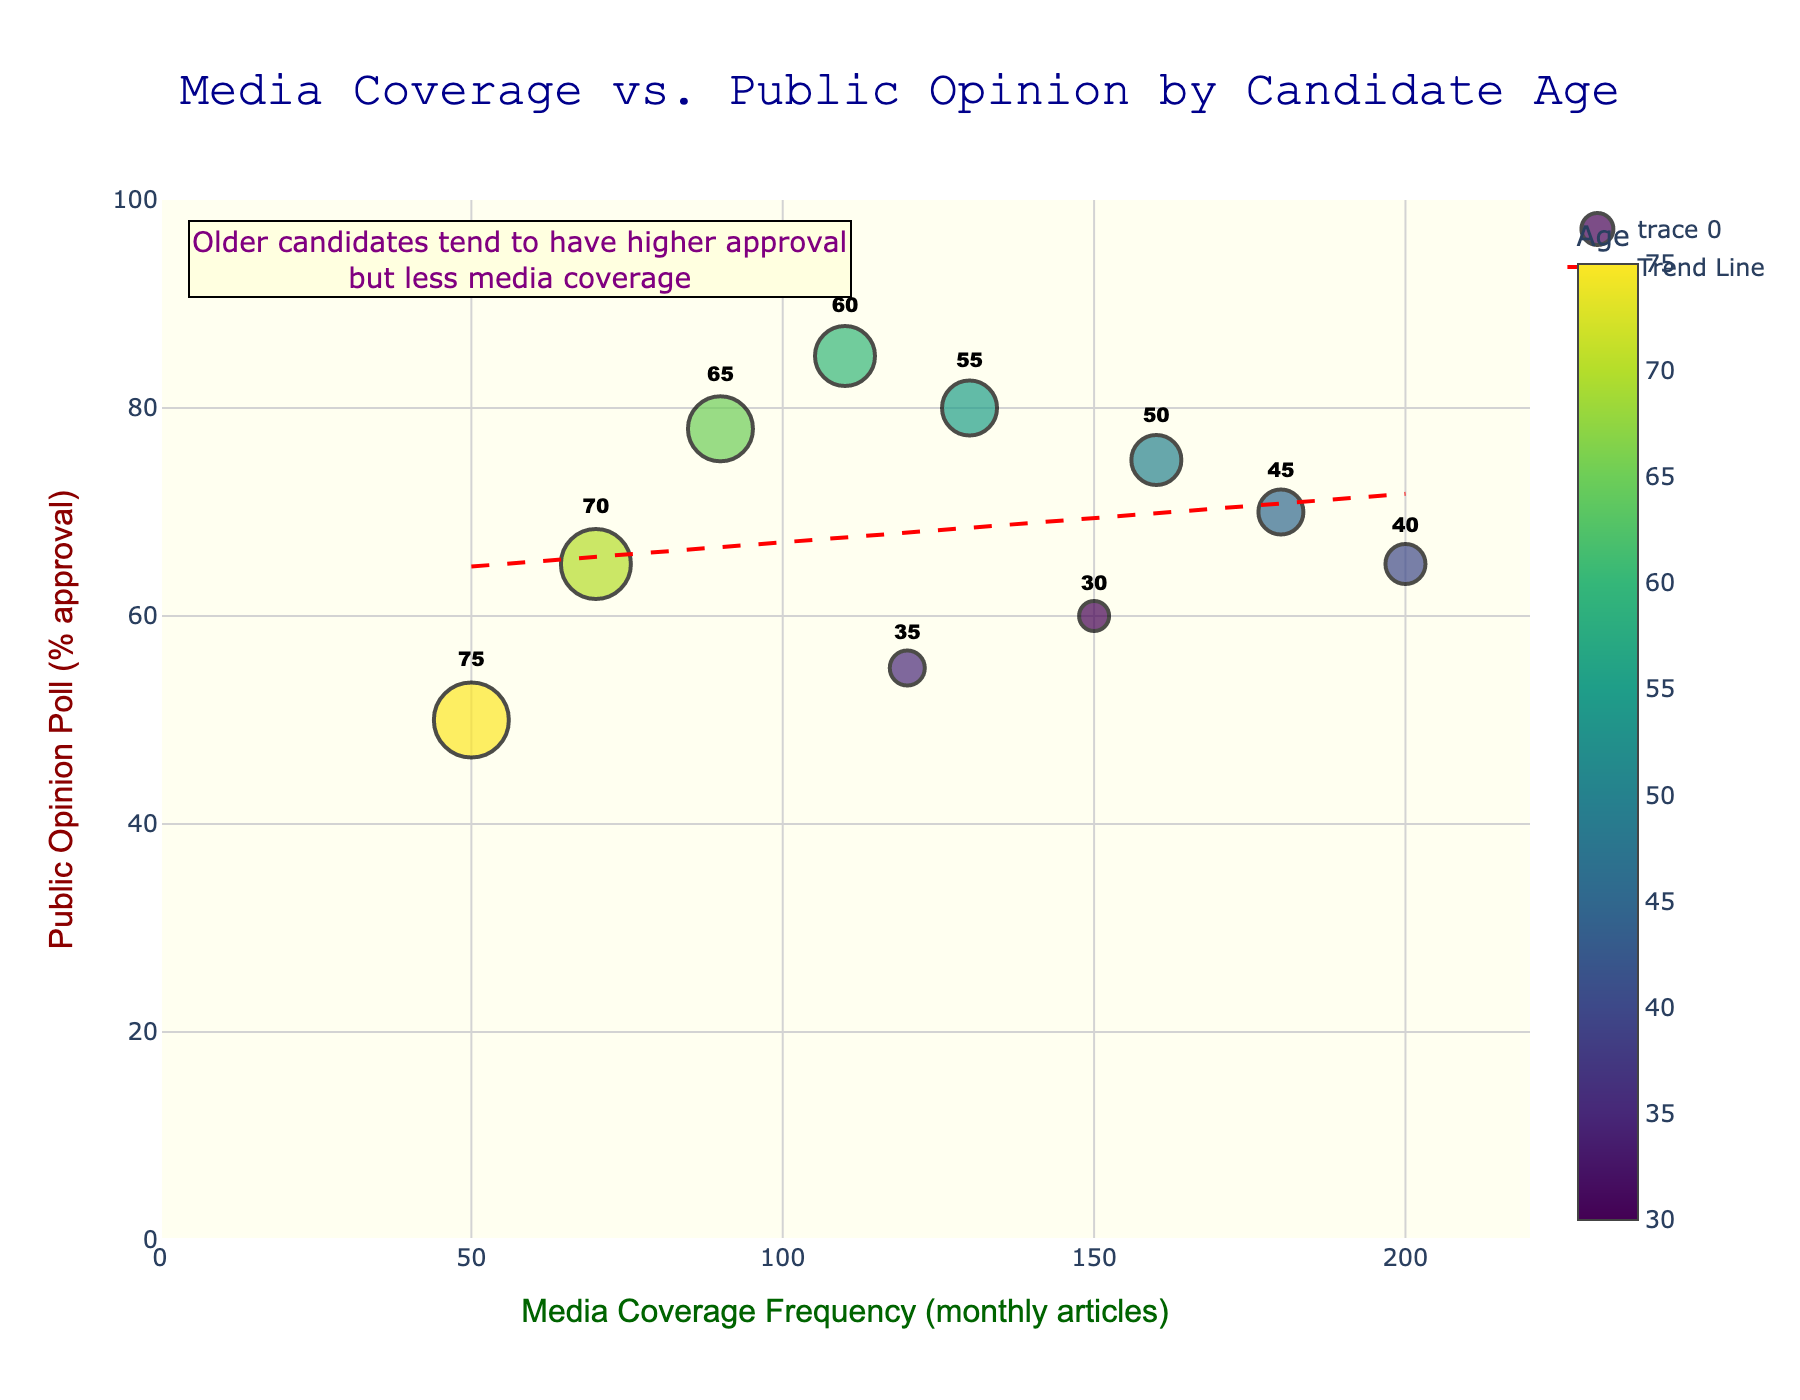What is the title of the scatter plot? The title is displayed at the top of the chart. It reads "Media Coverage vs. Public Opinion by Candidate Age".
Answer: Media Coverage vs. Public Opinion by Candidate Age Which age group has the highest public opinion approval? The y-axis represents public opinion approval, and the data points are labeled with age. The point at 85% approval corresponds to the age 60.
Answer: 60 How many candidates have a media coverage frequency greater than 100 monthly articles? Look at the x-axis and count the number of data points to the right of the 100 mark. These correspond to ages 30, 35, 40, 45, 50, and 55.
Answer: 6 What relationship does the trend line suggest between media coverage frequency and public opinion approval? The trend line is a red dashed line that indicates the overall trend of the data points. It slopes downward, suggesting a negative relationship.
Answer: Negative relationship Which candidate age has the lowest media coverage frequency and what is their public opinion approval rate? The lowest media coverage frequency on the x-axis is 50. The corresponding data point shows 50% approval for age 75.
Answer: 75, 50% How does the public opinion approval of the 45-year-old candidate compare to that of the 75-year-old candidate? The y-axis gives the approval rates for these ages. The 45-year-old has 70% approval while the 75-year-old has 50%. 70% is greater than 50%.
Answer: The 45-year-old candidate has higher approval What is the average public opinion approval for candidates aged 50 and 60? The approval for age 50 is 75%, and for age 60 is 85%. The average is (75 + 85) / 2 = 80%.
Answer: 80% Does media coverage frequency increase or decrease with candidate age? By observing the trend of the data points and the annotation, it says that older candidates have less media coverage, indicating a decrease.
Answer: Decrease What does the annotation in the chart say? The annotation is located in the upper left of the chart and reads: "Older candidates tend to have higher approval but less media coverage".
Answer: Older candidates tend to have higher approval but less media coverage Which candidate age shows the most media coverage frequency and what is their public opinion approval? The highest media coverage on the x-axis is 200. The corresponding data point shows 65% approval for age 40.
Answer: 40, 65% 